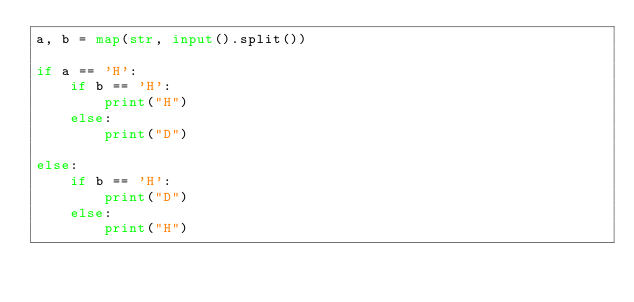Convert code to text. <code><loc_0><loc_0><loc_500><loc_500><_Python_>a, b = map(str, input().split())

if a == 'H':
    if b == 'H':
        print("H")
    else:
        print("D")

else:
    if b == 'H':
        print("D")
    else:
        print("H")
</code> 